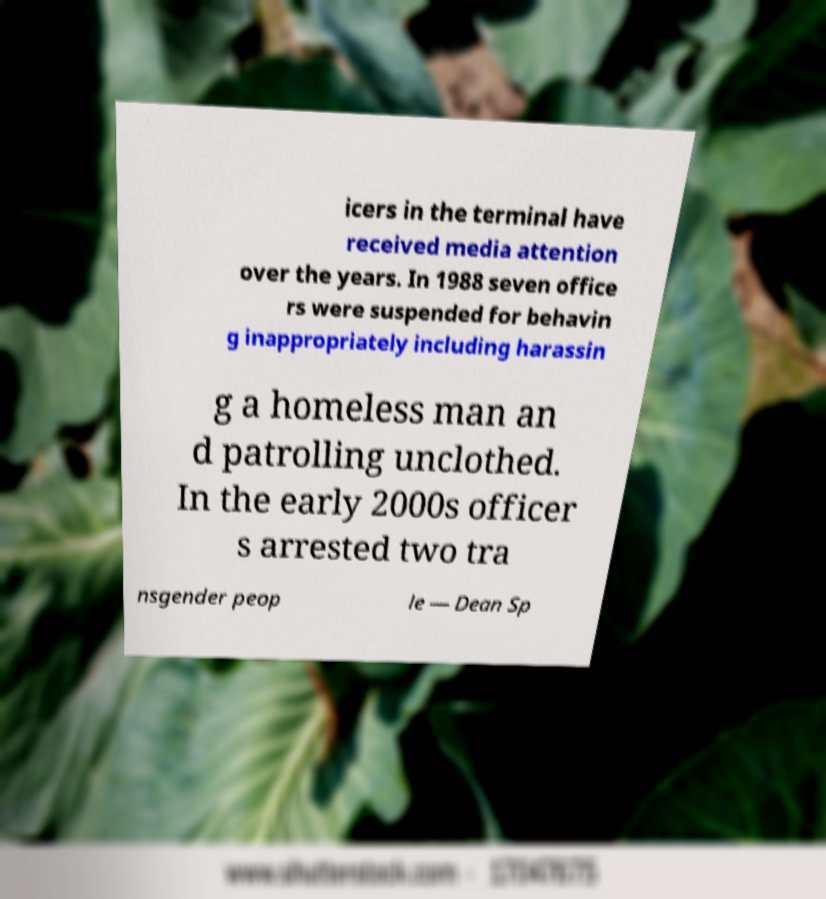What messages or text are displayed in this image? I need them in a readable, typed format. icers in the terminal have received media attention over the years. In 1988 seven office rs were suspended for behavin g inappropriately including harassin g a homeless man an d patrolling unclothed. In the early 2000s officer s arrested two tra nsgender peop le — Dean Sp 